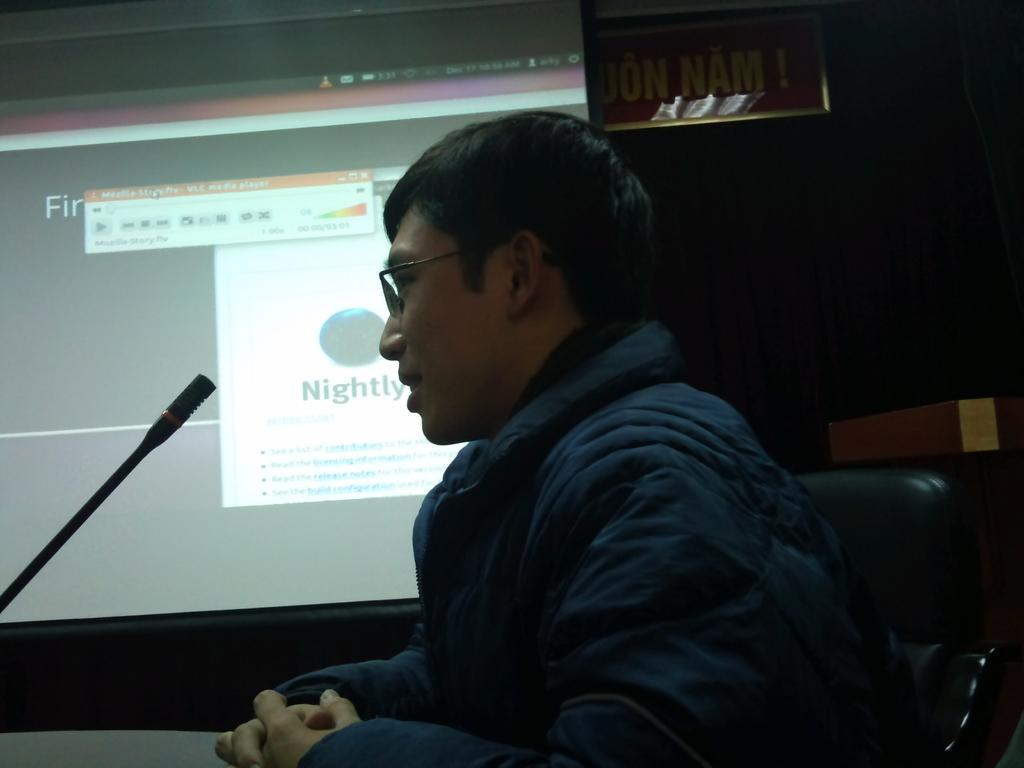Who is present in the image? There is a person in the image. What is the person wearing? The person is wearing clothes. What is the person doing in the image? The person is sitting on a chair and in front of a mic. What can be seen on the left side of the image? There is a screen on the left side of the image. What type of crate is visible in the image? There is no crate present in the image. 